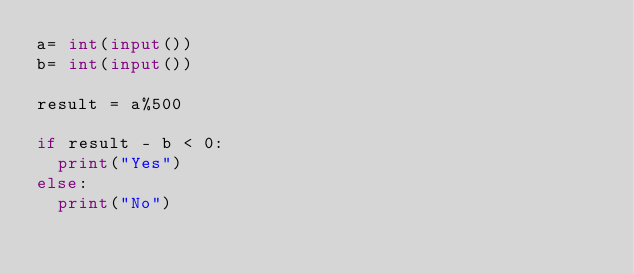Convert code to text. <code><loc_0><loc_0><loc_500><loc_500><_Python_>a= int(input())
b= int(input())

result = a%500

if result - b < 0:
  print("Yes")
else:
  print("No")</code> 